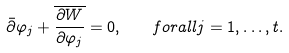Convert formula to latex. <formula><loc_0><loc_0><loc_500><loc_500>\bar { \partial } \varphi _ { j } + \overline { \frac { \partial W } { \partial \varphi _ { j } } } = 0 , \quad f o r a l l j = 1 , \dots , t .</formula> 